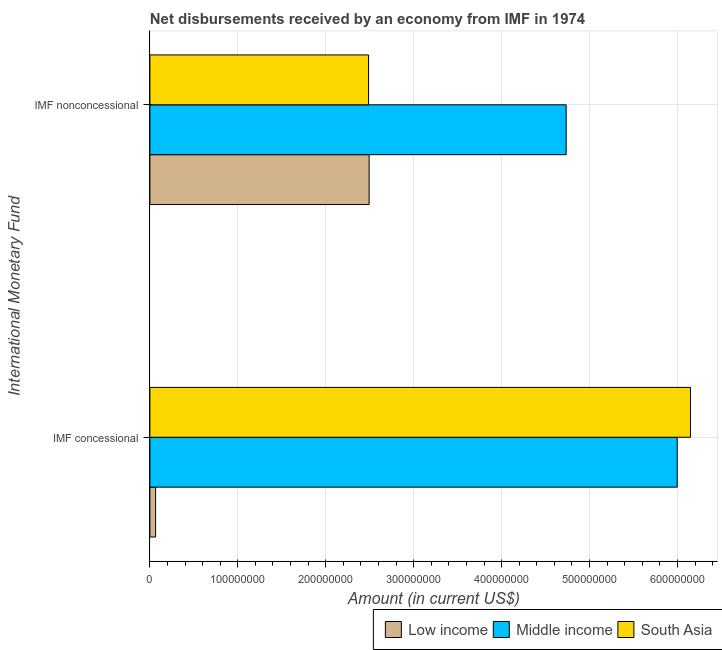Are the number of bars on each tick of the Y-axis equal?
Provide a succinct answer. Yes. How many bars are there on the 2nd tick from the top?
Provide a short and direct response. 3. How many bars are there on the 1st tick from the bottom?
Provide a short and direct response. 3. What is the label of the 1st group of bars from the top?
Make the answer very short. IMF nonconcessional. What is the net non concessional disbursements from imf in South Asia?
Provide a short and direct response. 2.49e+08. Across all countries, what is the maximum net concessional disbursements from imf?
Provide a short and direct response. 6.15e+08. Across all countries, what is the minimum net non concessional disbursements from imf?
Make the answer very short. 2.49e+08. In which country was the net concessional disbursements from imf minimum?
Give a very brief answer. Low income. What is the total net non concessional disbursements from imf in the graph?
Give a very brief answer. 9.72e+08. What is the difference between the net non concessional disbursements from imf in South Asia and that in Middle income?
Keep it short and to the point. -2.25e+08. What is the difference between the net concessional disbursements from imf in South Asia and the net non concessional disbursements from imf in Low income?
Provide a short and direct response. 3.65e+08. What is the average net non concessional disbursements from imf per country?
Keep it short and to the point. 3.24e+08. What is the difference between the net concessional disbursements from imf and net non concessional disbursements from imf in Middle income?
Offer a very short reply. 1.26e+08. What is the ratio of the net concessional disbursements from imf in South Asia to that in Low income?
Provide a short and direct response. 94.59. In how many countries, is the net concessional disbursements from imf greater than the average net concessional disbursements from imf taken over all countries?
Your answer should be very brief. 2. What does the 3rd bar from the bottom in IMF nonconcessional represents?
Your answer should be compact. South Asia. How many bars are there?
Provide a succinct answer. 6. Are the values on the major ticks of X-axis written in scientific E-notation?
Keep it short and to the point. No. Does the graph contain grids?
Your response must be concise. Yes. What is the title of the graph?
Give a very brief answer. Net disbursements received by an economy from IMF in 1974. What is the label or title of the X-axis?
Offer a very short reply. Amount (in current US$). What is the label or title of the Y-axis?
Give a very brief answer. International Monetary Fund. What is the Amount (in current US$) of Low income in IMF concessional?
Keep it short and to the point. 6.50e+06. What is the Amount (in current US$) of Middle income in IMF concessional?
Offer a very short reply. 6.00e+08. What is the Amount (in current US$) in South Asia in IMF concessional?
Ensure brevity in your answer.  6.15e+08. What is the Amount (in current US$) in Low income in IMF nonconcessional?
Make the answer very short. 2.49e+08. What is the Amount (in current US$) in Middle income in IMF nonconcessional?
Make the answer very short. 4.73e+08. What is the Amount (in current US$) of South Asia in IMF nonconcessional?
Offer a very short reply. 2.49e+08. Across all International Monetary Fund, what is the maximum Amount (in current US$) of Low income?
Ensure brevity in your answer.  2.49e+08. Across all International Monetary Fund, what is the maximum Amount (in current US$) in Middle income?
Make the answer very short. 6.00e+08. Across all International Monetary Fund, what is the maximum Amount (in current US$) of South Asia?
Your answer should be compact. 6.15e+08. Across all International Monetary Fund, what is the minimum Amount (in current US$) in Low income?
Provide a succinct answer. 6.50e+06. Across all International Monetary Fund, what is the minimum Amount (in current US$) of Middle income?
Give a very brief answer. 4.73e+08. Across all International Monetary Fund, what is the minimum Amount (in current US$) of South Asia?
Provide a short and direct response. 2.49e+08. What is the total Amount (in current US$) in Low income in the graph?
Your answer should be very brief. 2.56e+08. What is the total Amount (in current US$) of Middle income in the graph?
Offer a terse response. 1.07e+09. What is the total Amount (in current US$) in South Asia in the graph?
Provide a succinct answer. 8.64e+08. What is the difference between the Amount (in current US$) in Low income in IMF concessional and that in IMF nonconcessional?
Provide a short and direct response. -2.43e+08. What is the difference between the Amount (in current US$) in Middle income in IMF concessional and that in IMF nonconcessional?
Provide a succinct answer. 1.26e+08. What is the difference between the Amount (in current US$) of South Asia in IMF concessional and that in IMF nonconcessional?
Offer a terse response. 3.66e+08. What is the difference between the Amount (in current US$) of Low income in IMF concessional and the Amount (in current US$) of Middle income in IMF nonconcessional?
Provide a succinct answer. -4.67e+08. What is the difference between the Amount (in current US$) in Low income in IMF concessional and the Amount (in current US$) in South Asia in IMF nonconcessional?
Provide a succinct answer. -2.42e+08. What is the difference between the Amount (in current US$) of Middle income in IMF concessional and the Amount (in current US$) of South Asia in IMF nonconcessional?
Keep it short and to the point. 3.51e+08. What is the average Amount (in current US$) of Low income per International Monetary Fund?
Your response must be concise. 1.28e+08. What is the average Amount (in current US$) in Middle income per International Monetary Fund?
Keep it short and to the point. 5.37e+08. What is the average Amount (in current US$) in South Asia per International Monetary Fund?
Keep it short and to the point. 4.32e+08. What is the difference between the Amount (in current US$) of Low income and Amount (in current US$) of Middle income in IMF concessional?
Keep it short and to the point. -5.93e+08. What is the difference between the Amount (in current US$) of Low income and Amount (in current US$) of South Asia in IMF concessional?
Ensure brevity in your answer.  -6.08e+08. What is the difference between the Amount (in current US$) of Middle income and Amount (in current US$) of South Asia in IMF concessional?
Provide a succinct answer. -1.50e+07. What is the difference between the Amount (in current US$) in Low income and Amount (in current US$) in Middle income in IMF nonconcessional?
Offer a very short reply. -2.24e+08. What is the difference between the Amount (in current US$) in Middle income and Amount (in current US$) in South Asia in IMF nonconcessional?
Your answer should be very brief. 2.25e+08. What is the ratio of the Amount (in current US$) of Low income in IMF concessional to that in IMF nonconcessional?
Your answer should be very brief. 0.03. What is the ratio of the Amount (in current US$) in Middle income in IMF concessional to that in IMF nonconcessional?
Make the answer very short. 1.27. What is the ratio of the Amount (in current US$) in South Asia in IMF concessional to that in IMF nonconcessional?
Your response must be concise. 2.47. What is the difference between the highest and the second highest Amount (in current US$) of Low income?
Offer a very short reply. 2.43e+08. What is the difference between the highest and the second highest Amount (in current US$) of Middle income?
Ensure brevity in your answer.  1.26e+08. What is the difference between the highest and the second highest Amount (in current US$) in South Asia?
Your response must be concise. 3.66e+08. What is the difference between the highest and the lowest Amount (in current US$) of Low income?
Your answer should be very brief. 2.43e+08. What is the difference between the highest and the lowest Amount (in current US$) of Middle income?
Provide a short and direct response. 1.26e+08. What is the difference between the highest and the lowest Amount (in current US$) of South Asia?
Ensure brevity in your answer.  3.66e+08. 